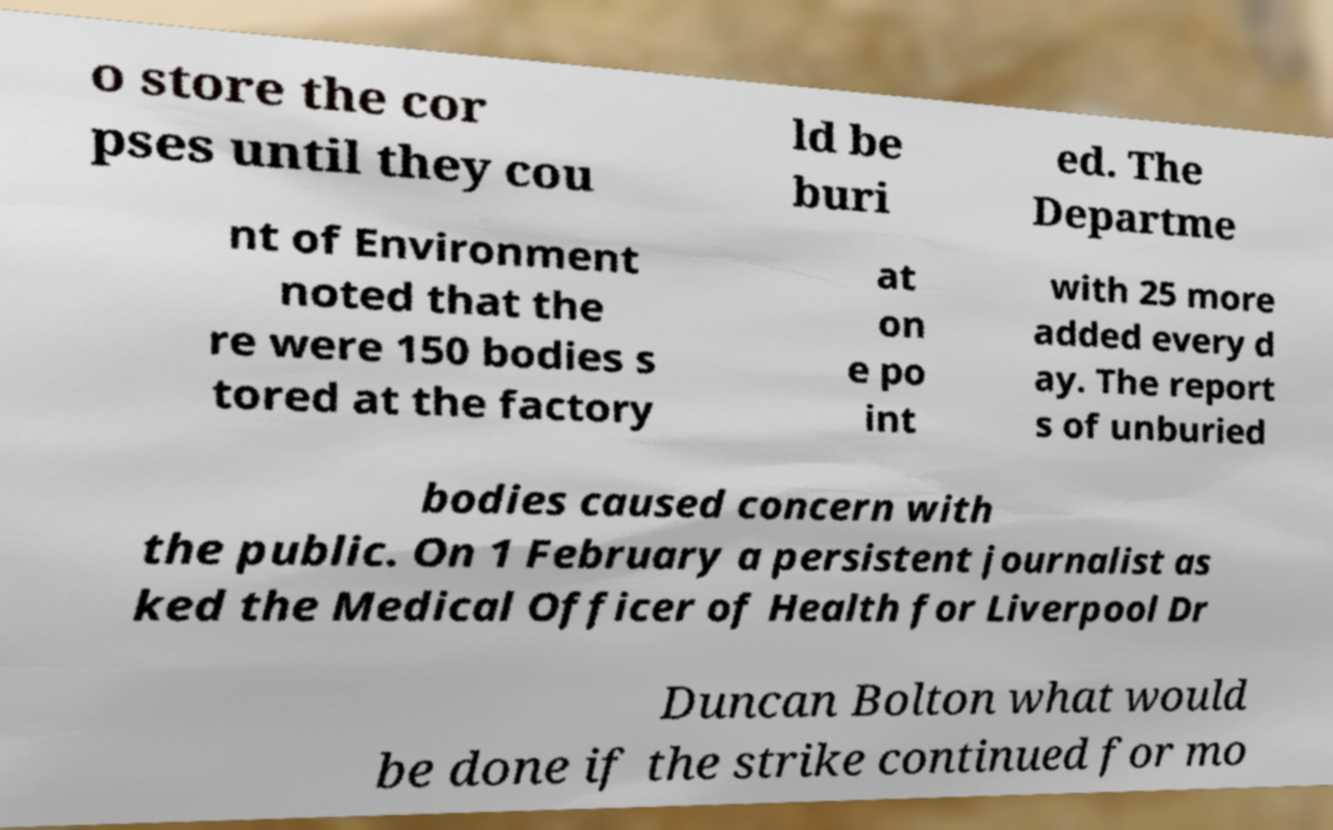Please read and relay the text visible in this image. What does it say? o store the cor pses until they cou ld be buri ed. The Departme nt of Environment noted that the re were 150 bodies s tored at the factory at on e po int with 25 more added every d ay. The report s of unburied bodies caused concern with the public. On 1 February a persistent journalist as ked the Medical Officer of Health for Liverpool Dr Duncan Bolton what would be done if the strike continued for mo 